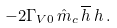<formula> <loc_0><loc_0><loc_500><loc_500>- 2 \Gamma _ { V 0 } \, \hat { m } _ { c } \, \overline { h } \, h \, .</formula> 